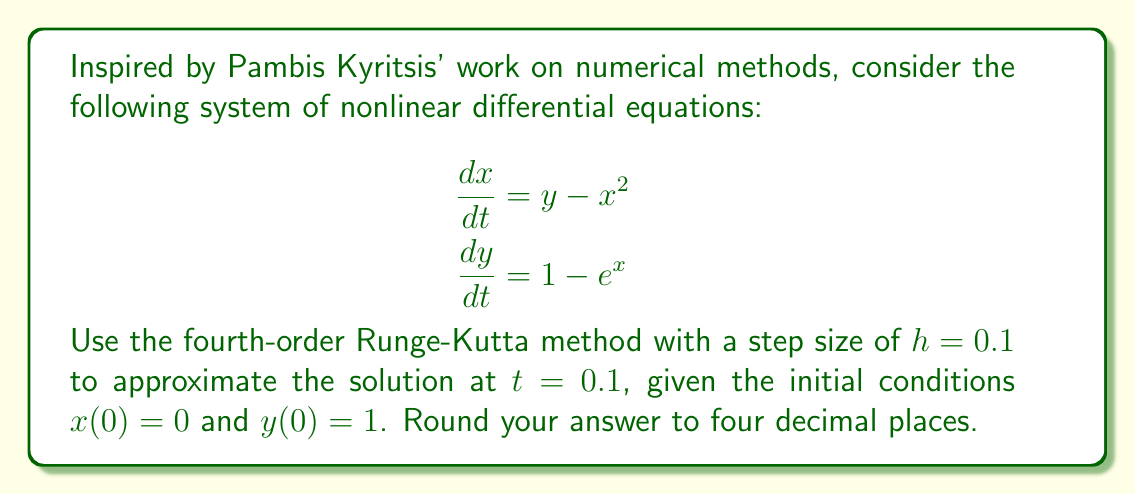Solve this math problem. To solve this system using the fourth-order Runge-Kutta method, we follow these steps:

1) Define the functions:
   $f_1(x, y) = y - x^2$
   $f_2(x, y) = 1 - e^x$

2) Set initial conditions: $x_0 = 0$, $y_0 = 1$, $t_0 = 0$, $h = 0.1$

3) Calculate the Runge-Kutta coefficients:

   $k_1 = hf_1(x_0, y_0) = h(y_0 - x_0^2) = 0.1(1 - 0^2) = 0.1$
   $l_1 = hf_2(x_0, y_0) = h(1 - e^{x_0}) = 0.1(1 - e^0) = 0$

   $k_2 = hf_1(x_0 + \frac{k_1}{2}, y_0 + \frac{l_1}{2}) = 0.1((1 + 0/2) - (0 + 0.1/2)^2) = 0.099875$
   $l_2 = hf_2(x_0 + \frac{k_1}{2}, y_0 + \frac{l_1}{2}) = 0.1(1 - e^{0.05}) = -0.005127$

   $k_3 = hf_1(x_0 + \frac{k_2}{2}, y_0 + \frac{l_2}{2}) = 0.1((1 - 0.005127/2) - (0 + 0.099875/2)^2) = 0.099501$
   $l_3 = hf_2(x_0 + \frac{k_2}{2}, y_0 + \frac{l_2}{2}) = 0.1(1 - e^{0.049938}) = -0.005115$

   $k_4 = hf_1(x_0 + k_3, y_0 + l_3) = 0.1((1 - 0.005115) - (0 + 0.099501)^2) = 0.098759$
   $l_4 = hf_2(x_0 + k_3, y_0 + l_3) = 0.1(1 - e^{0.099501}) = -0.010453$

4) Update $x$ and $y$:

   $x_1 = x_0 + \frac{1}{6}(k_1 + 2k_2 + 2k_3 + k_4) = 0 + \frac{1}{6}(0.1 + 2(0.099875) + 2(0.099501) + 0.098759) = 0.0995$

   $y_1 = y_0 + \frac{1}{6}(l_1 + 2l_2 + 2l_3 + l_4) = 1 + \frac{1}{6}(0 + 2(-0.005127) + 2(-0.005115) - 0.010453) = 0.9948$

Therefore, at $t = 0.1$, $x \approx 0.0995$ and $y \approx 0.9948$.
Answer: $x(0.1) \approx 0.0995$, $y(0.1) \approx 0.9948$ 